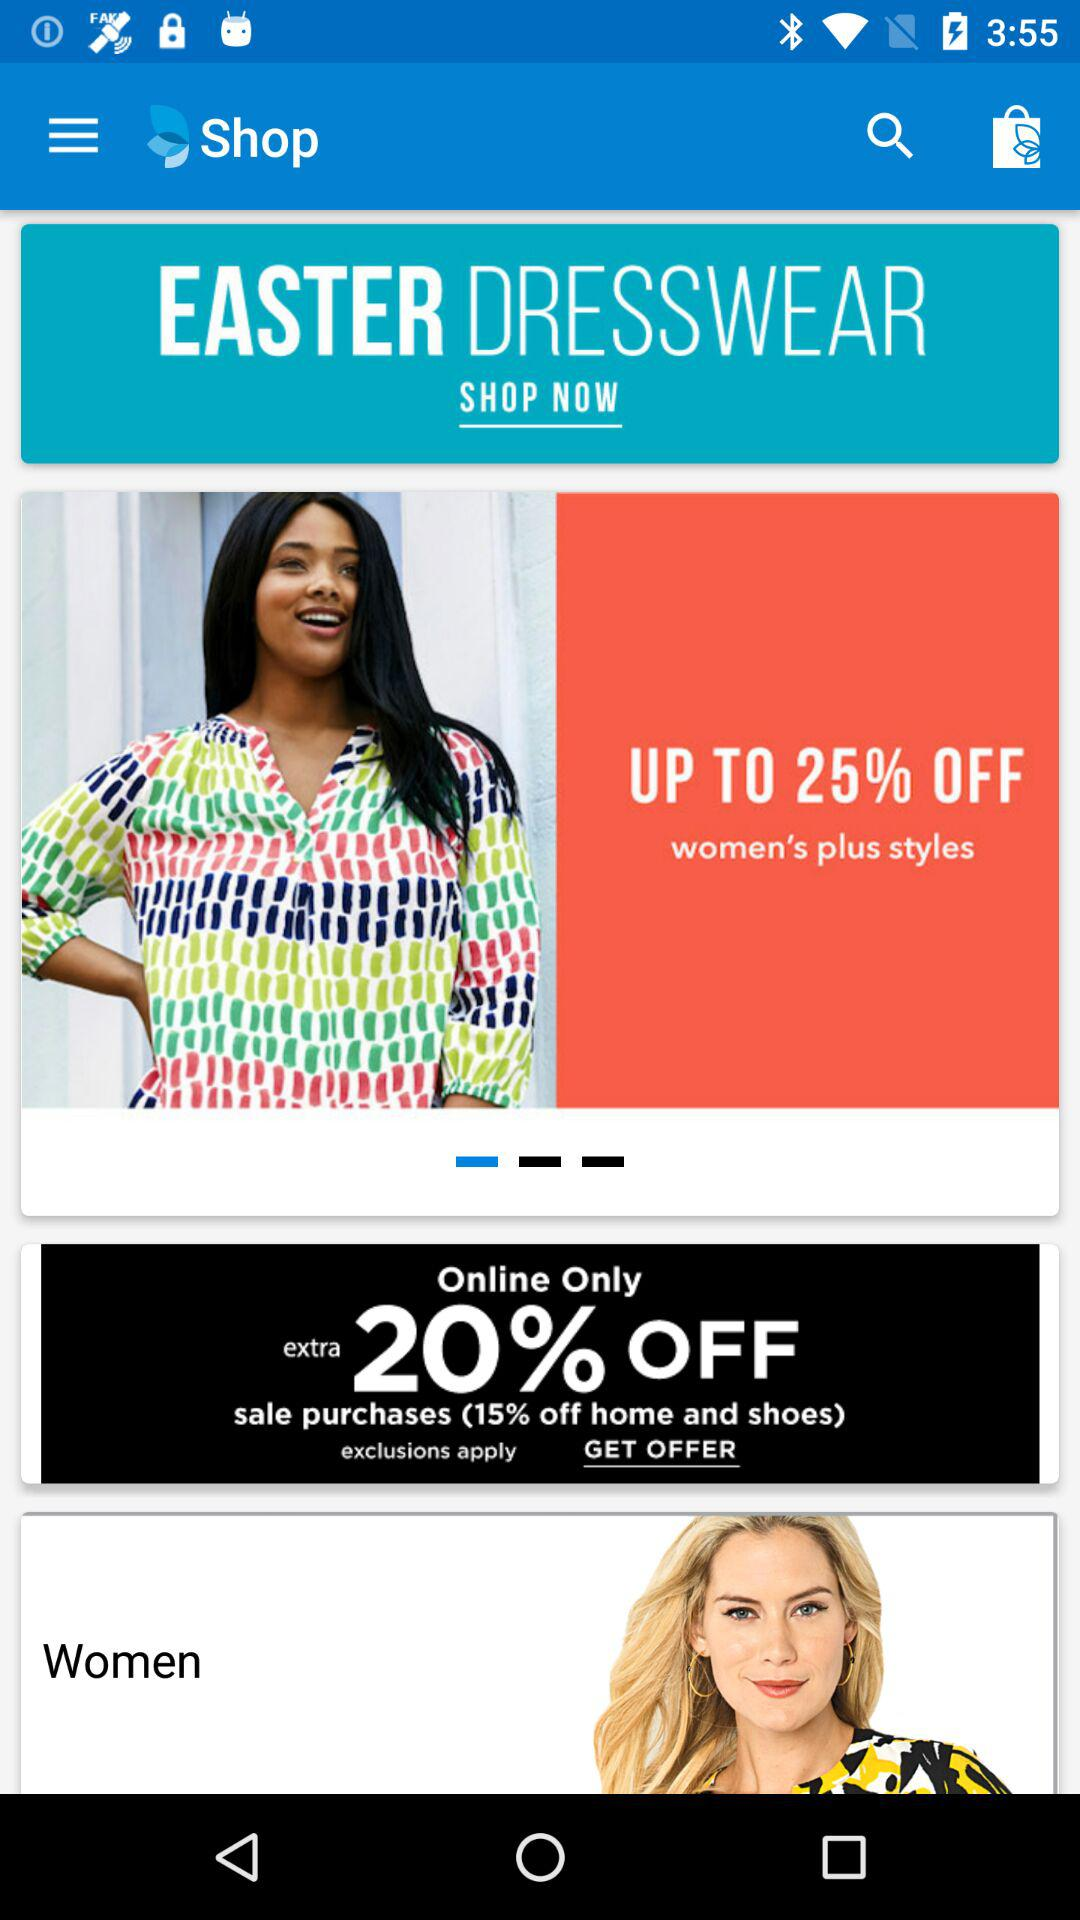What percentage is off on women's plus styles? There is up to 25% off on women's plus styles. 